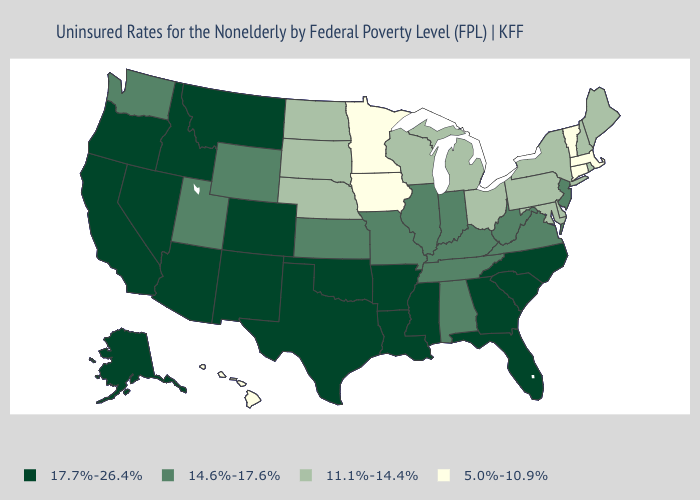Name the states that have a value in the range 14.6%-17.6%?
Be succinct. Alabama, Illinois, Indiana, Kansas, Kentucky, Missouri, New Jersey, Tennessee, Utah, Virginia, Washington, West Virginia, Wyoming. Name the states that have a value in the range 17.7%-26.4%?
Give a very brief answer. Alaska, Arizona, Arkansas, California, Colorado, Florida, Georgia, Idaho, Louisiana, Mississippi, Montana, Nevada, New Mexico, North Carolina, Oklahoma, Oregon, South Carolina, Texas. What is the value of Ohio?
Short answer required. 11.1%-14.4%. What is the value of West Virginia?
Quick response, please. 14.6%-17.6%. Does Iowa have a lower value than Minnesota?
Keep it brief. No. What is the value of Maine?
Give a very brief answer. 11.1%-14.4%. What is the highest value in the USA?
Give a very brief answer. 17.7%-26.4%. What is the value of Pennsylvania?
Give a very brief answer. 11.1%-14.4%. Which states hav the highest value in the Northeast?
Be succinct. New Jersey. What is the value of Alabama?
Answer briefly. 14.6%-17.6%. Among the states that border Michigan , which have the highest value?
Short answer required. Indiana. Name the states that have a value in the range 11.1%-14.4%?
Quick response, please. Delaware, Maine, Maryland, Michigan, Nebraska, New Hampshire, New York, North Dakota, Ohio, Pennsylvania, Rhode Island, South Dakota, Wisconsin. What is the lowest value in the Northeast?
Keep it brief. 5.0%-10.9%. What is the value of Mississippi?
Give a very brief answer. 17.7%-26.4%. What is the value of New York?
Keep it brief. 11.1%-14.4%. 